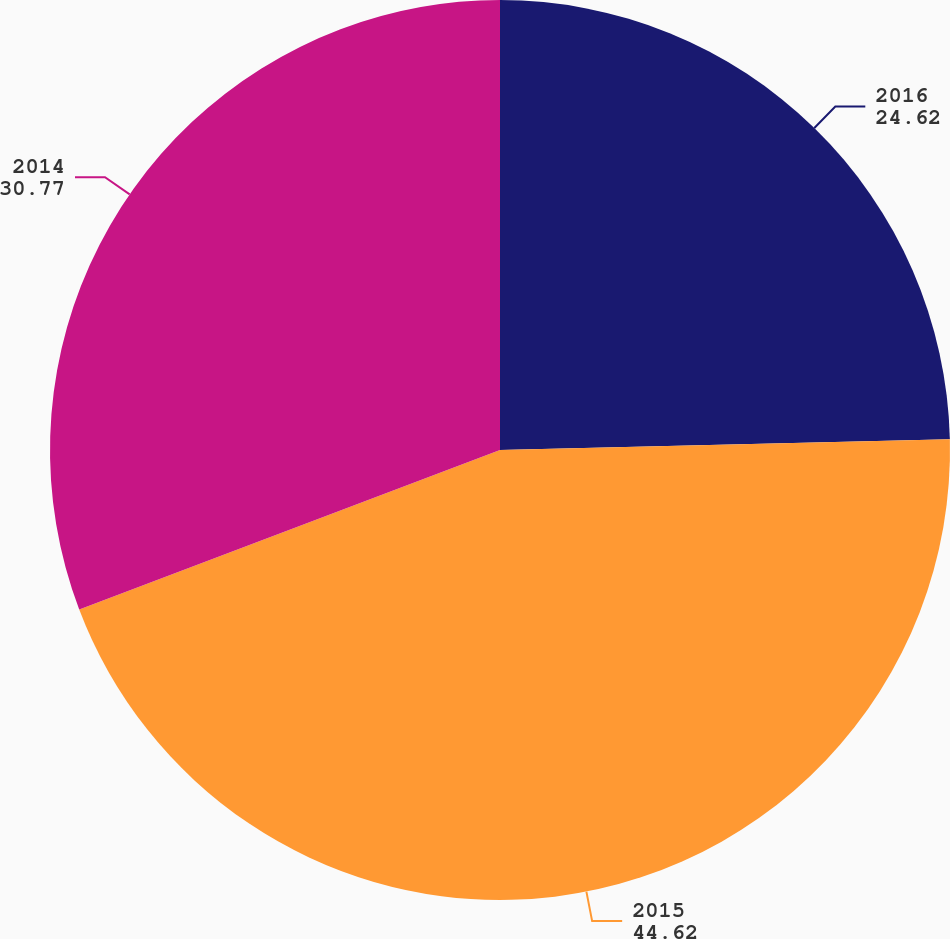Convert chart. <chart><loc_0><loc_0><loc_500><loc_500><pie_chart><fcel>2016<fcel>2015<fcel>2014<nl><fcel>24.62%<fcel>44.62%<fcel>30.77%<nl></chart> 